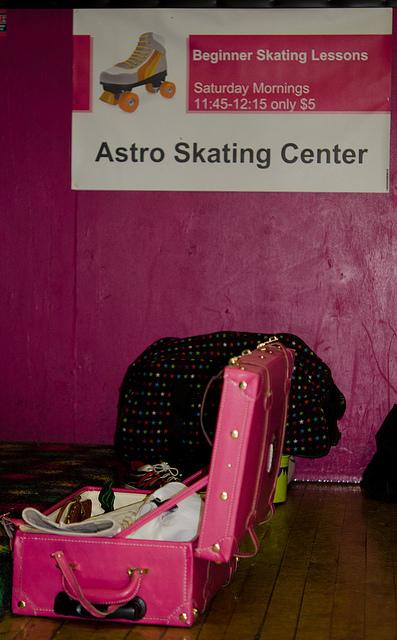What time is Beginners skating lessons?
Be succinct. 11:45-12:15. How many suitcases?
Be succinct. 1. What is being taught?
Concise answer only. Skating. How many suitcases are there?
Give a very brief answer. 1. How much do the lessons cost?
Short answer required. $5. How many sets of suitcases are there?
Short answer required. 1. What color are the walls?
Short answer required. Pink. 